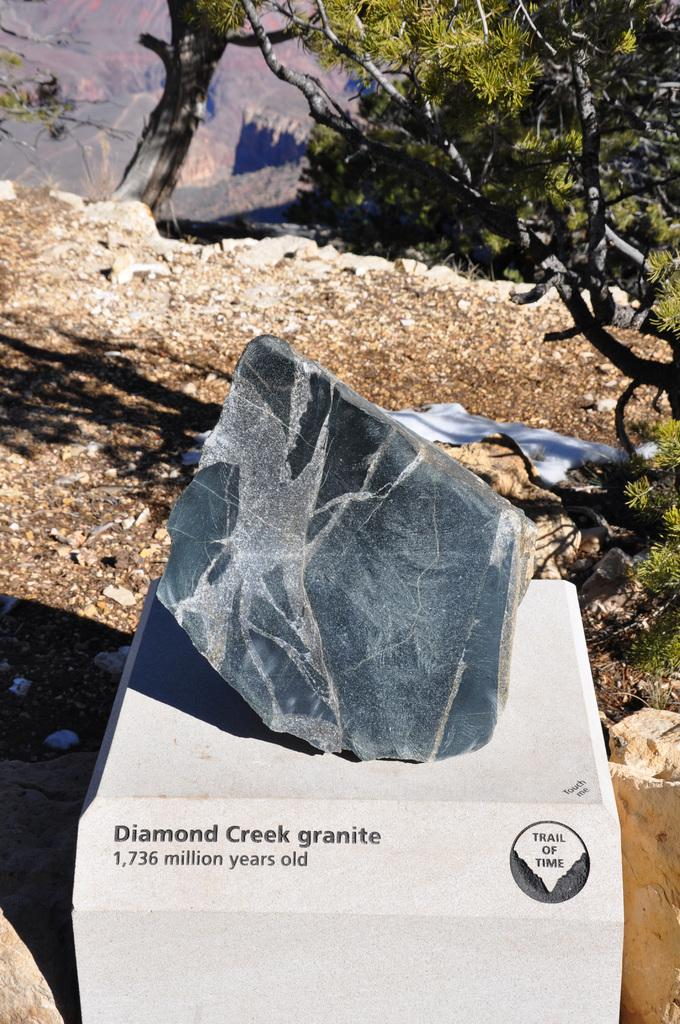What is on the wall in the image? There is a rock and text on the wall in the image. What can be seen in the background of the image? There is a mountain and trees visible in the background of the image. What is at the bottom of the image? There is ground visible at the bottom of the image. What is present on the ground in the image? There are stones on the ground in the image. Can you see any tomatoes growing on the mountain in the image? There are no tomatoes visible in the image; only a mountain, trees, and ground are present. What type of tub is located near the rock on the wall in the image? There is no tub present in the image; it features a rock, text, and other elements mentioned in the facts. 